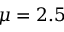<formula> <loc_0><loc_0><loc_500><loc_500>\mu = 2 . 5</formula> 